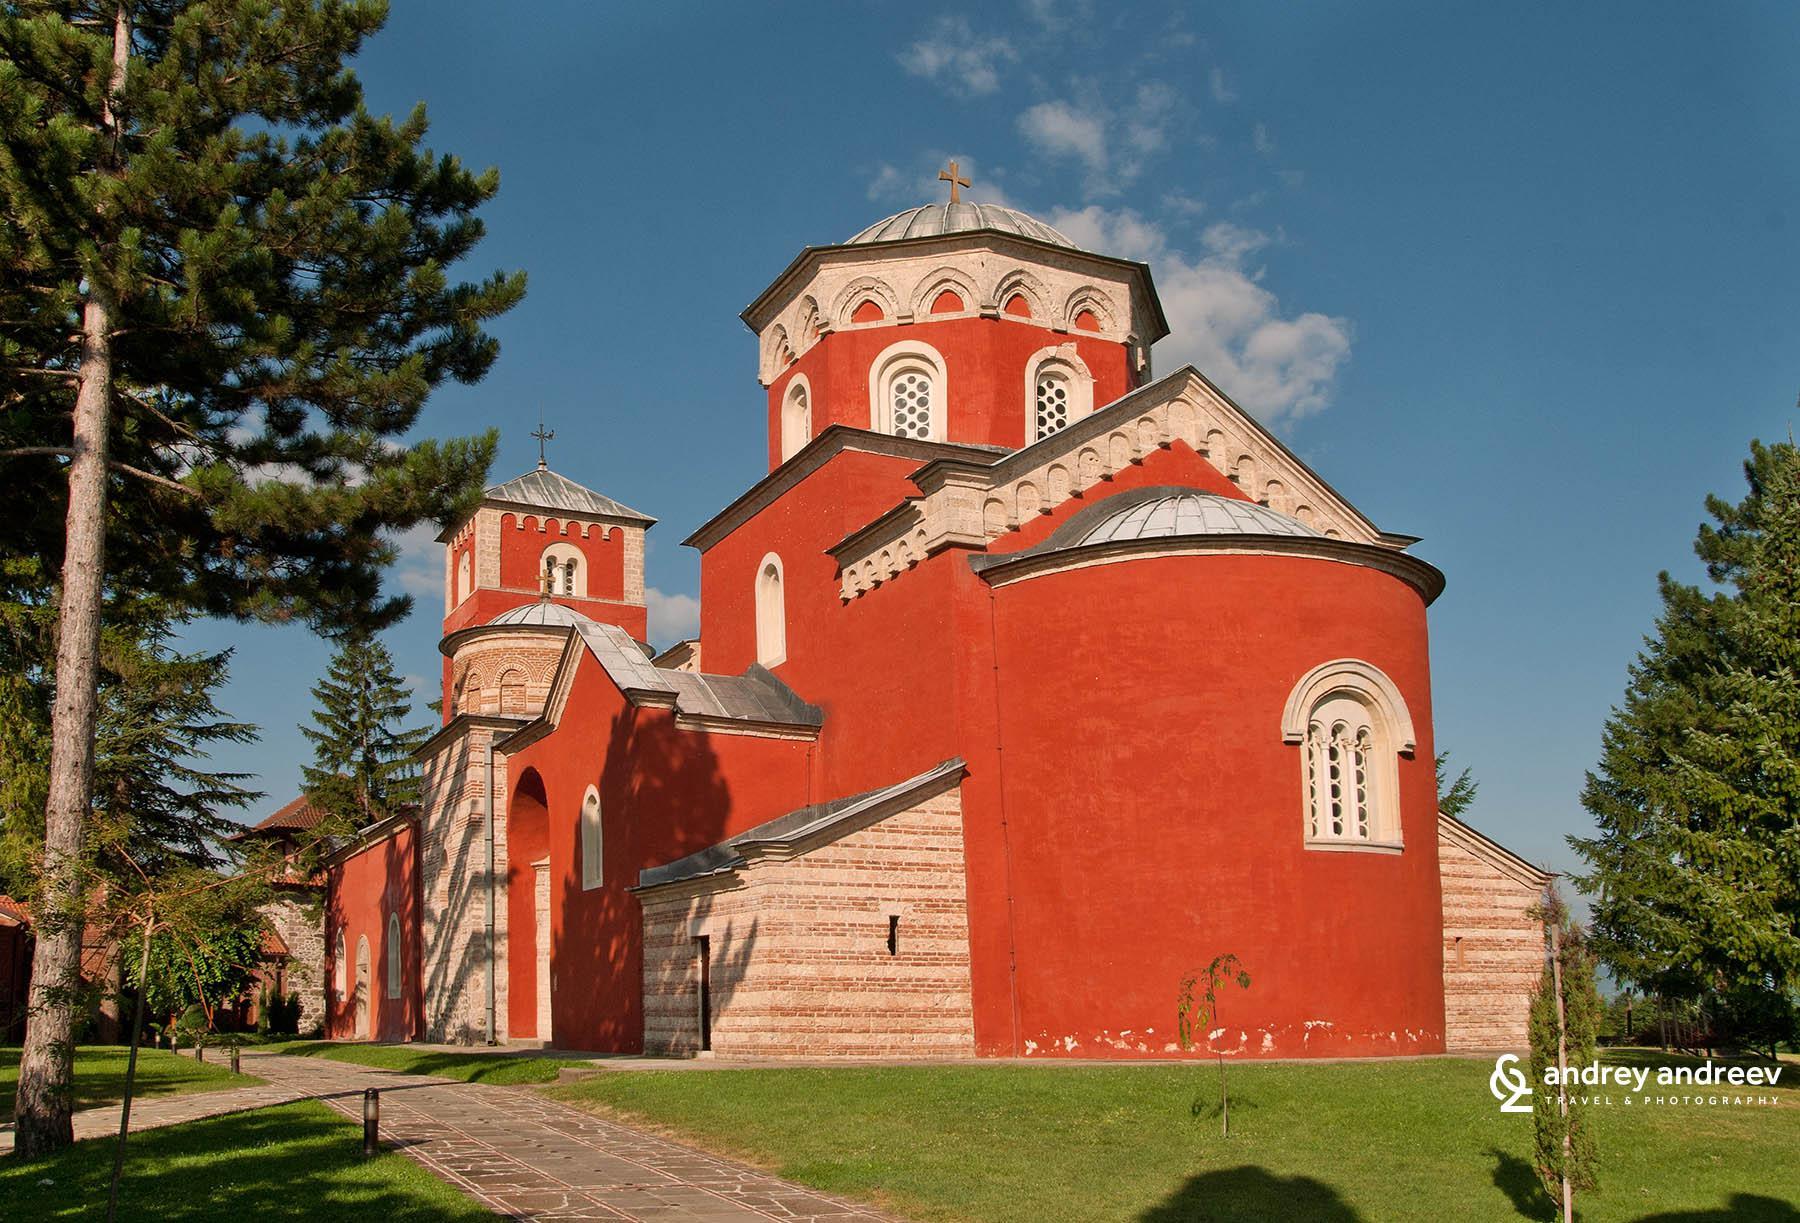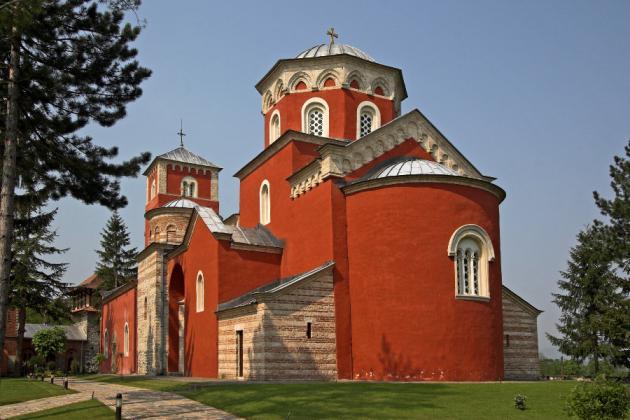The first image is the image on the left, the second image is the image on the right. Considering the images on both sides, is "At least one of the buildings in the image on the left is bright orange." valid? Answer yes or no. Yes. The first image is the image on the left, the second image is the image on the right. Analyze the images presented: Is the assertion "Left image shows a reddish-orange building with a dome-topped tower with flat sides featuring round-topped windows." valid? Answer yes or no. Yes. 